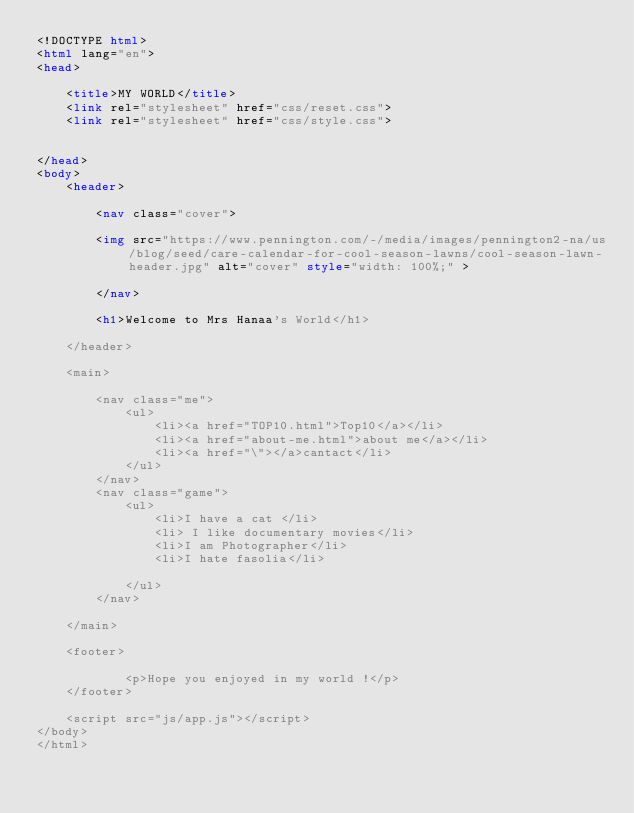Convert code to text. <code><loc_0><loc_0><loc_500><loc_500><_HTML_><!DOCTYPE html>
<html lang="en">
<head>
    
    <title>MY WORLD</title>
    <link rel="stylesheet" href="css/reset.css">
    <link rel="stylesheet" href="css/style.css">


</head>
<body>
    <header>

        <nav class="cover">

        <img src="https://www.pennington.com/-/media/images/pennington2-na/us/blog/seed/care-calendar-for-cool-season-lawns/cool-season-lawn-header.jpg" alt="cover" style="width: 100%;" >

        </nav> 

        <h1>Welcome to Mrs Hanaa's World</h1>
          
    </header>

    <main>
        
        <nav class="me">
            <ul>
                <li><a href="TOP10.html">Top10</a></li>
                <li><a href="about-me.html">about me</a></li>
                <li><a href="\"></a>cantact</li>
            </ul>
        </nav>
        <nav class="game">
            <ul>
                <li>I have a cat </li>
                <li> I like documentary movies</li>
                <li>I am Photographer</li>
                <li>I hate fasolia</li>
                
            </ul>
        </nav>

    </main>

    <footer>

            <p>Hope you enjoyed in my world !</p>
    </footer>

    <script src="js/app.js"></script>
</body>
</html></code> 